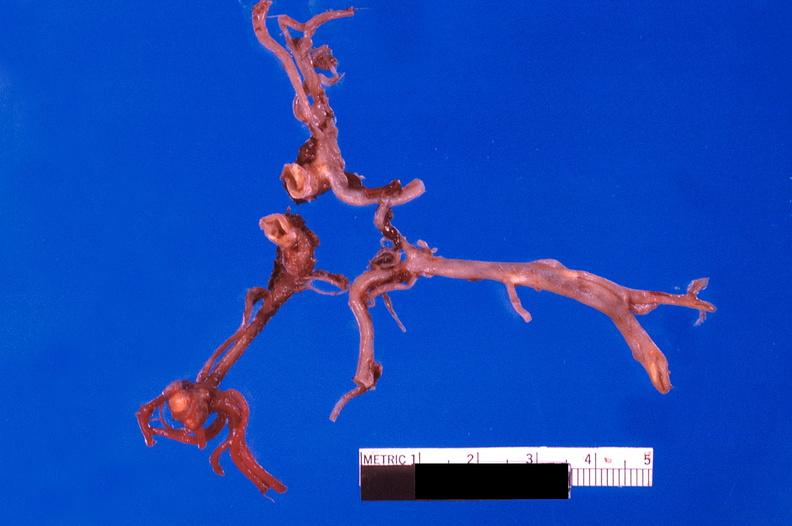s aorta present?
Answer the question using a single word or phrase. No 